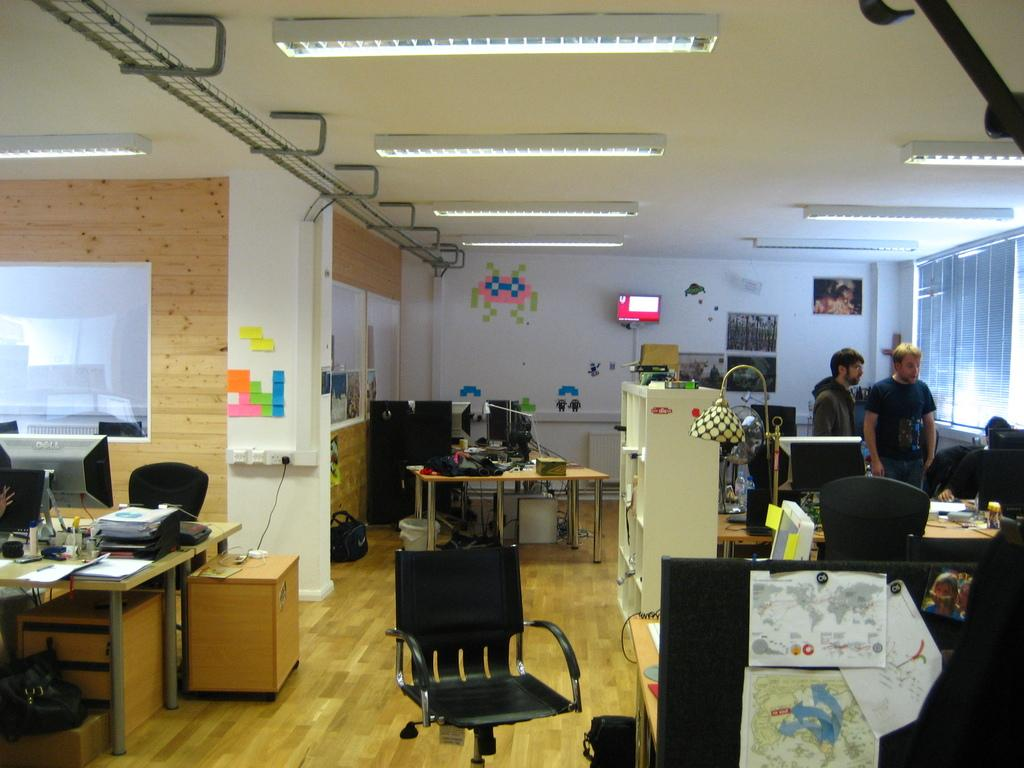What is the color of the wall in the image? The wall in the image is white. What can be seen on the wall in the image? There is a screen on the wall in the image. What type of furniture is present in the image? There are tables and chairs in the image. What are the people in the image doing? There are people standing and sitting in the image. What electronic device is present in the image? There is a television in the image. What is on the table with the television? There is a lamp on a table in the image. What type of technology is present on the table with the lamp? There are laptops on a table in the image. How many glasses are on the table with the laptops? There is no mention of glasses on the table with the laptops in the image. What type of comfort can be seen in the image? The image does not depict comfort as a subject or object. How many cats are present in the image? There are no cats present in the image. 